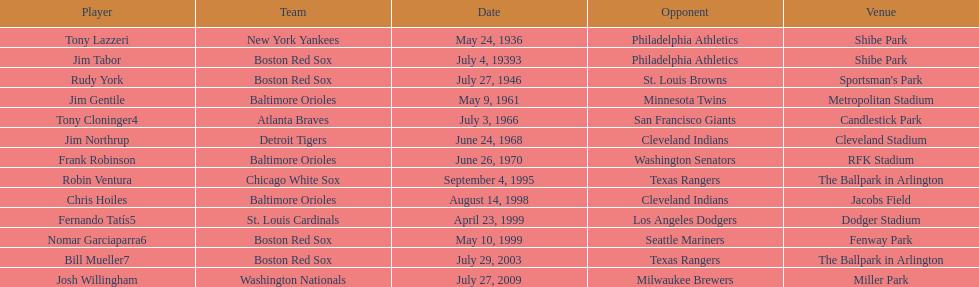Which teams faced off at miller park? Washington Nationals, Milwaukee Brewers. 